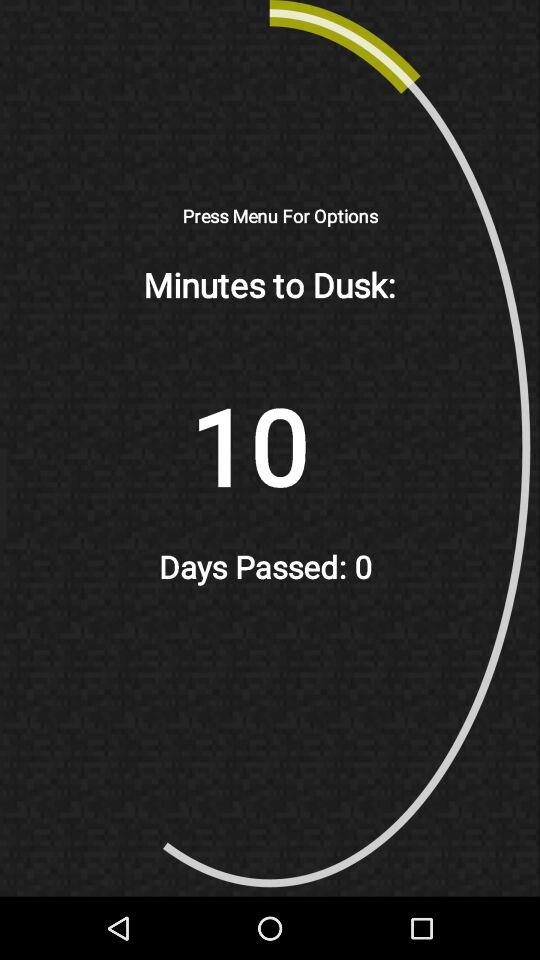How many days have passed?
Answer the question using a single word or phrase. 0 